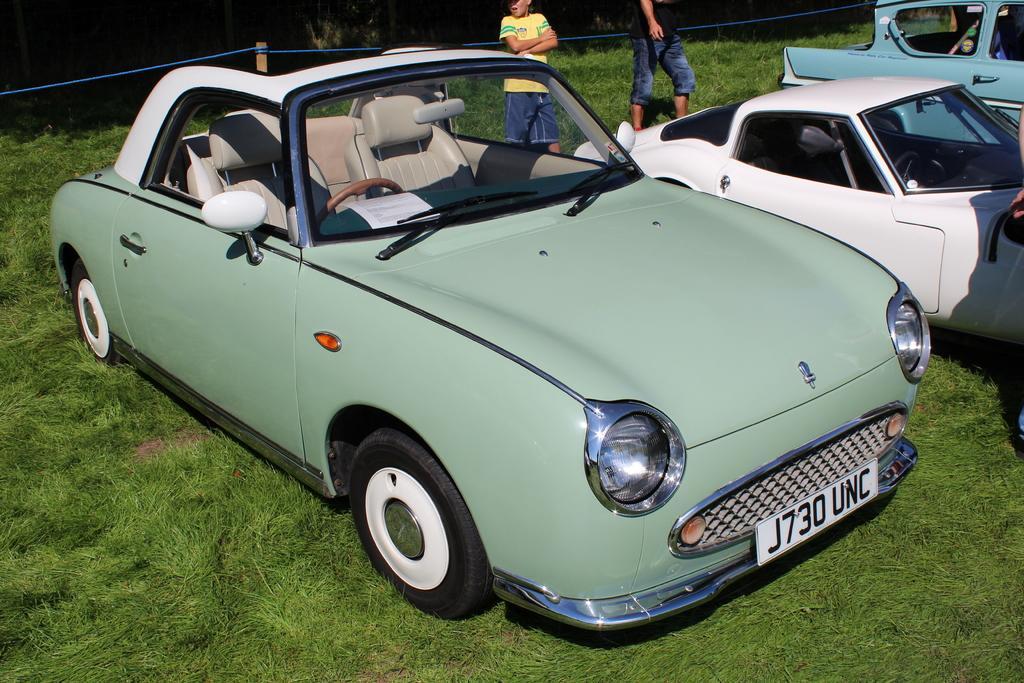In one or two sentences, can you explain what this image depicts? In this image we can see these cars are parked here on the grass, we can see two person standing here and we can see the fence in the background. 